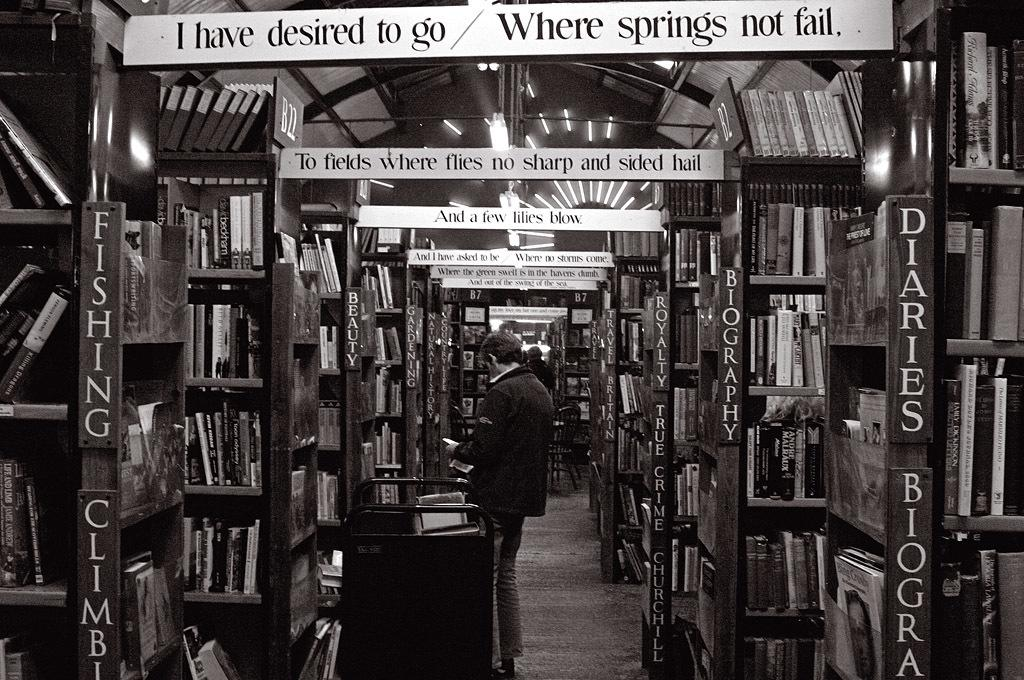<image>
Offer a succinct explanation of the picture presented. some quotes like I have Desired to Go at the top of a library 